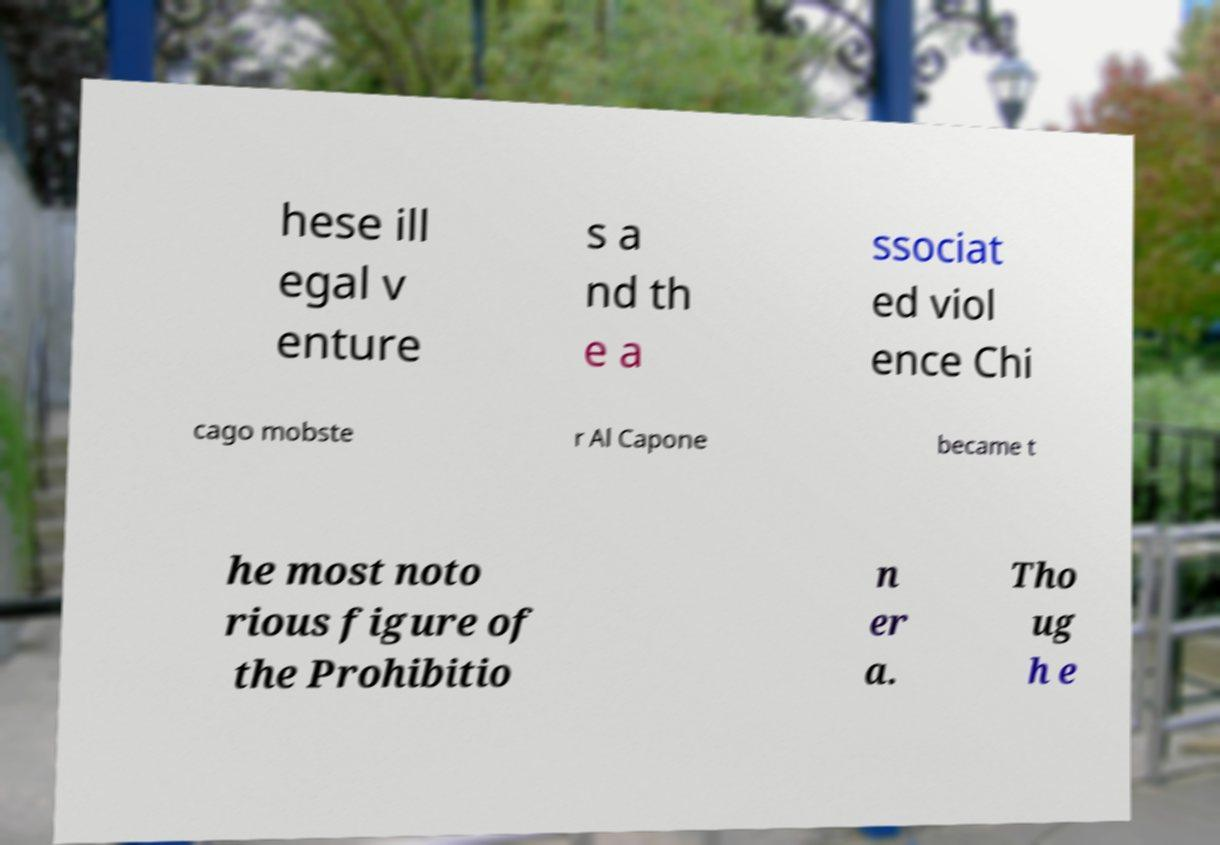I need the written content from this picture converted into text. Can you do that? hese ill egal v enture s a nd th e a ssociat ed viol ence Chi cago mobste r Al Capone became t he most noto rious figure of the Prohibitio n er a. Tho ug h e 